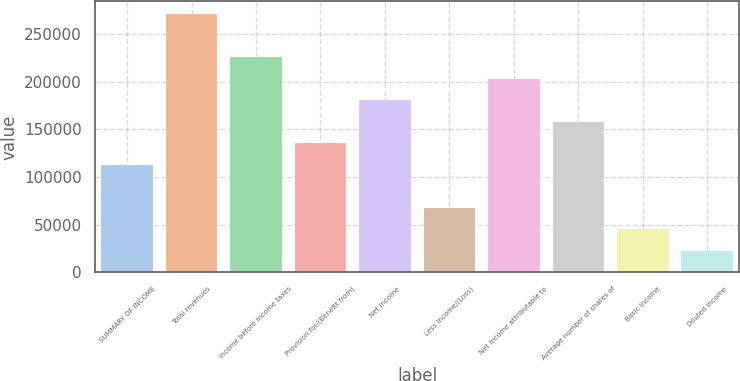Convert chart to OTSL. <chart><loc_0><loc_0><loc_500><loc_500><bar_chart><fcel>SUMMARY OF INCOME<fcel>Total revenues<fcel>Income before income taxes<fcel>Provision for/(Benefit from)<fcel>Net income<fcel>Less Income/(Loss)<fcel>Net income attributable to<fcel>Average number of shares of<fcel>Basic income<fcel>Diluted income<nl><fcel>112746<fcel>270589<fcel>225491<fcel>135295<fcel>180393<fcel>67647.7<fcel>202942<fcel>157844<fcel>45098.7<fcel>22549.6<nl></chart> 